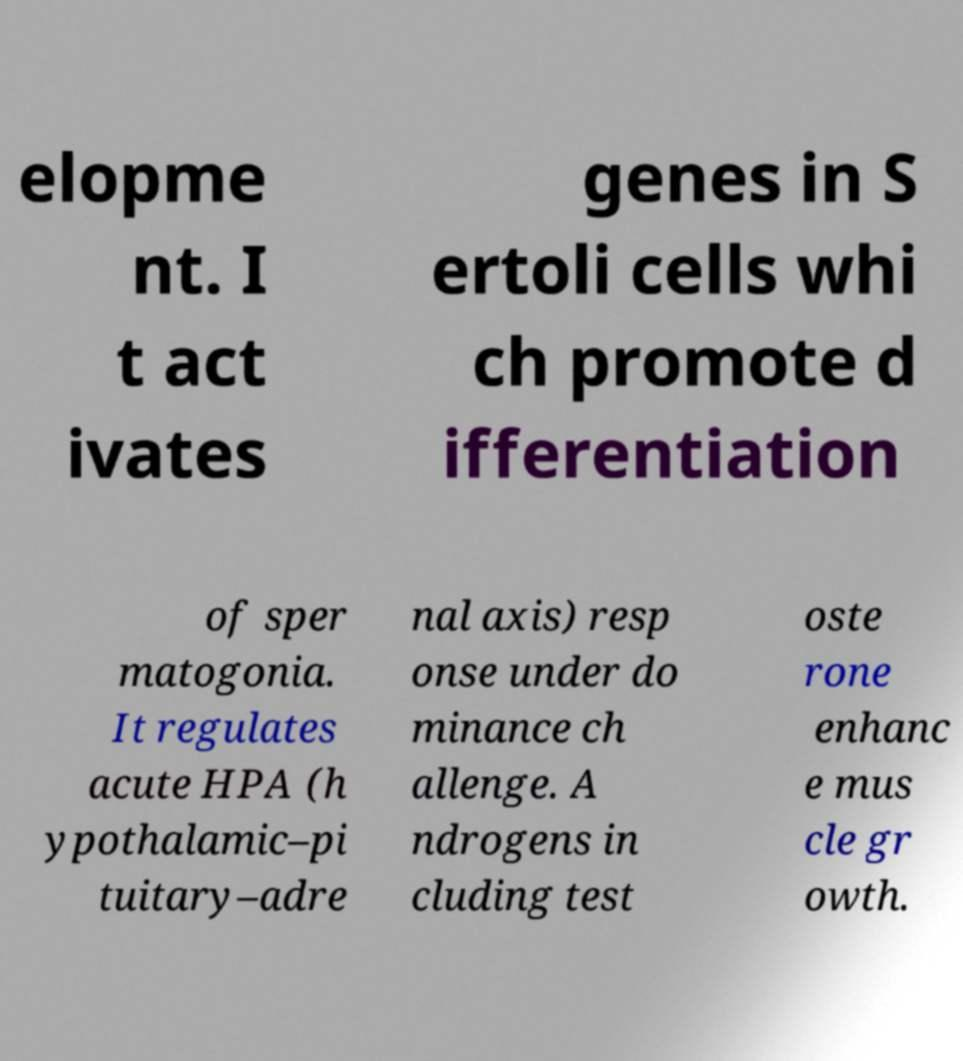There's text embedded in this image that I need extracted. Can you transcribe it verbatim? elopme nt. I t act ivates genes in S ertoli cells whi ch promote d ifferentiation of sper matogonia. It regulates acute HPA (h ypothalamic–pi tuitary–adre nal axis) resp onse under do minance ch allenge. A ndrogens in cluding test oste rone enhanc e mus cle gr owth. 